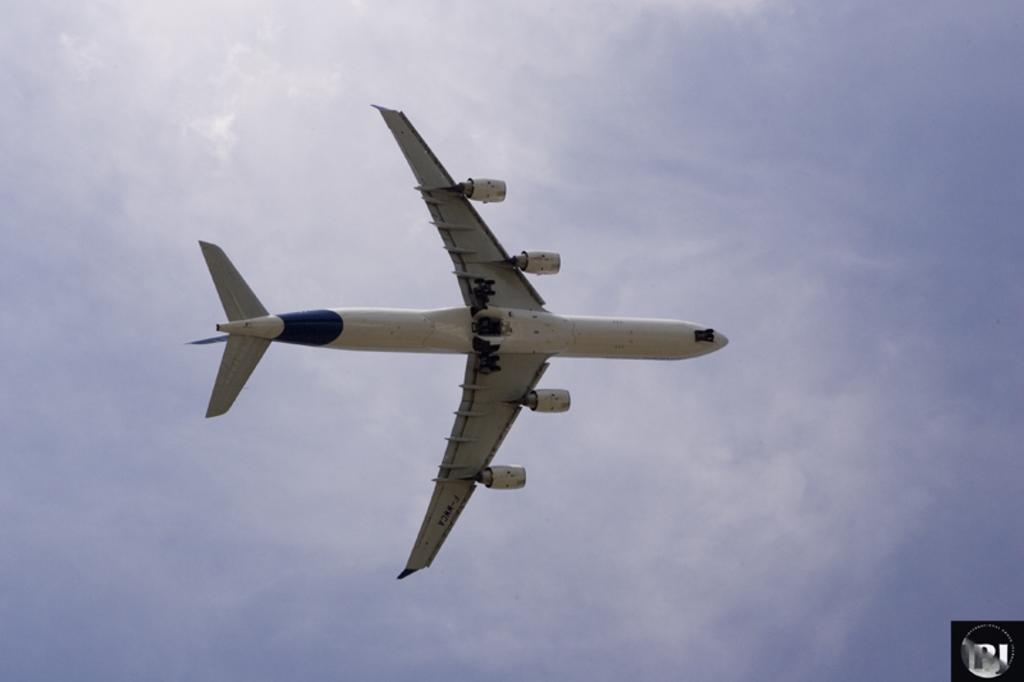What is the main subject of the image? The main subject of the image is an aeroplane. Can you describe the position of the aeroplane in the image? The aeroplane is in the air. What can be seen in the background of the image? There is sky visible in the background of the image. What type of chalk is being used to draw on the aeroplane's wing in the image? There is no chalk or drawing on the aeroplane's wing in the image. Can you describe the bat that is flying alongside the aeroplane in the image? There is no bat present in the image; the aeroplane is the only subject in the air. 